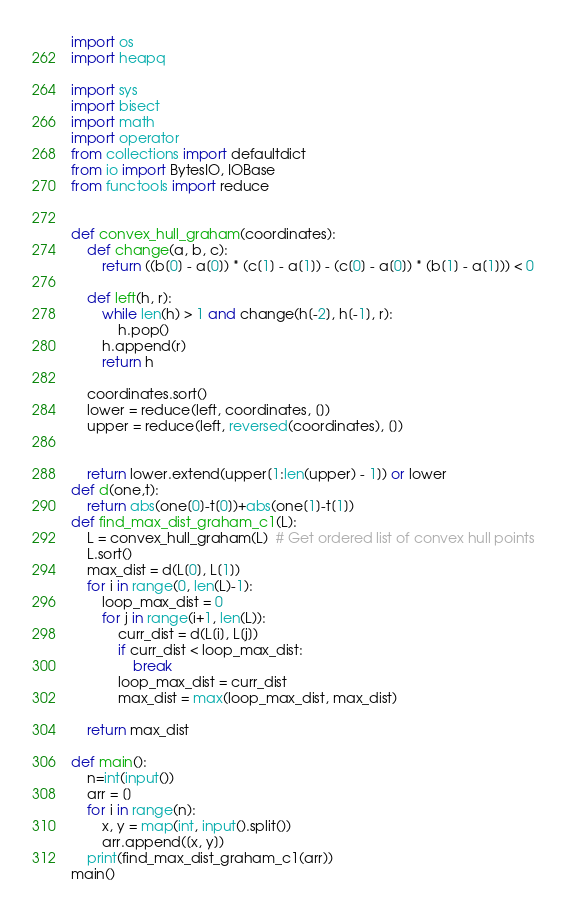<code> <loc_0><loc_0><loc_500><loc_500><_Python_>import os
import heapq

import sys
import bisect
import math
import operator
from collections import defaultdict
from io import BytesIO, IOBase
from functools import reduce


def convex_hull_graham(coordinates):
    def change(a, b, c):
        return ((b[0] - a[0]) * (c[1] - a[1]) - (c[0] - a[0]) * (b[1] - a[1])) < 0

    def left(h, r):
        while len(h) > 1 and change(h[-2], h[-1], r):
            h.pop()
        h.append(r)
        return h

    coordinates.sort()
    lower = reduce(left, coordinates, [])
    upper = reduce(left, reversed(coordinates), [])


    return lower.extend(upper[1:len(upper) - 1]) or lower
def d(one,t):
    return abs(one[0]-t[0])+abs(one[1]-t[1])
def find_max_dist_graham_c1(L):
    L = convex_hull_graham(L)  # Get ordered list of convex hull points
    L.sort()
    max_dist = d(L[0], L[1])
    for i in range(0, len(L)-1):
        loop_max_dist = 0
        for j in range(i+1, len(L)):
            curr_dist = d(L[i], L[j])
            if curr_dist < loop_max_dist:
                break
            loop_max_dist = curr_dist
            max_dist = max(loop_max_dist, max_dist)

    return max_dist

def main():
    n=int(input())
    arr = []
    for i in range(n):
        x, y = map(int, input().split())
        arr.append([x, y])
    print(find_max_dist_graham_c1(arr))
main()
</code> 